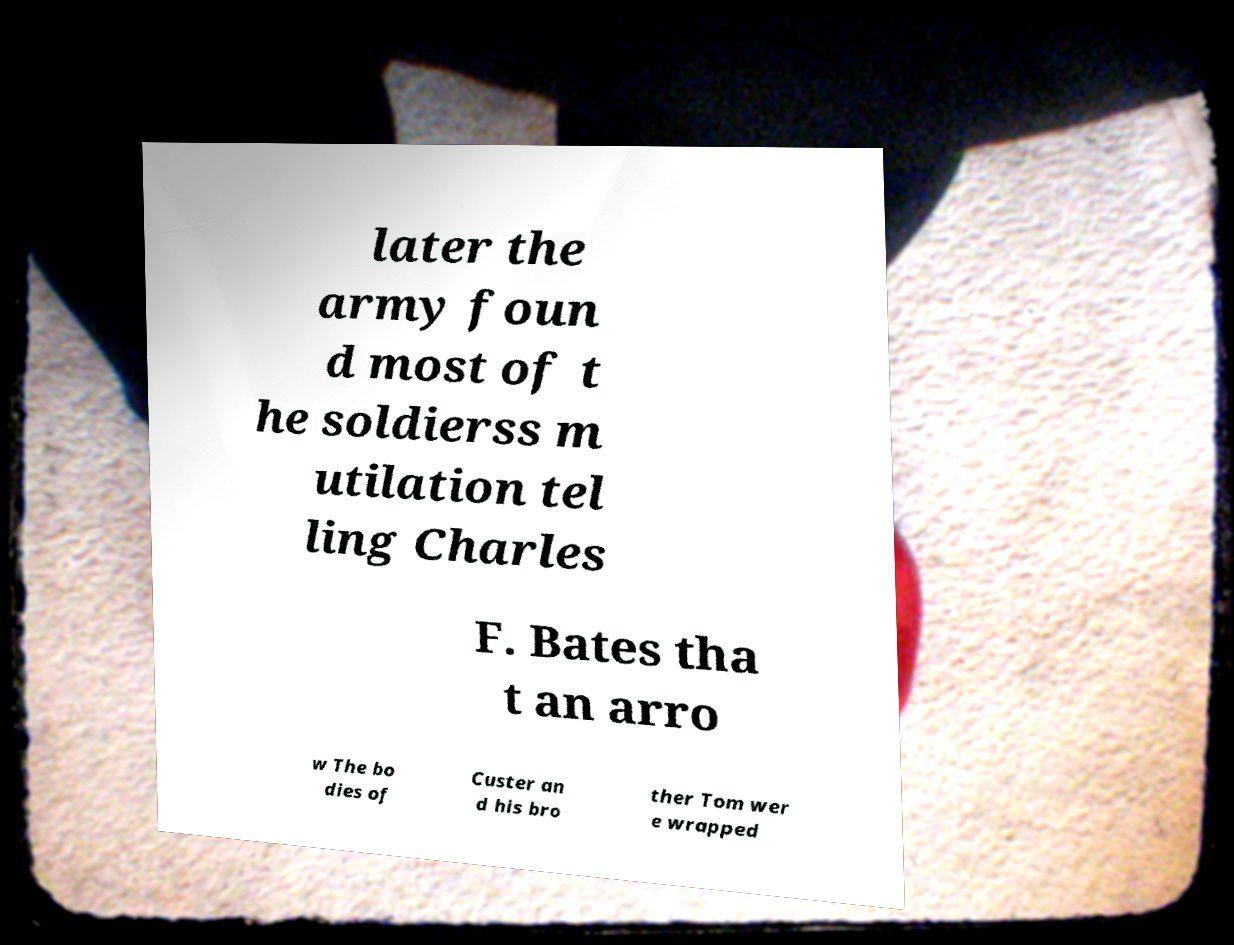There's text embedded in this image that I need extracted. Can you transcribe it verbatim? later the army foun d most of t he soldierss m utilation tel ling Charles F. Bates tha t an arro w The bo dies of Custer an d his bro ther Tom wer e wrapped 